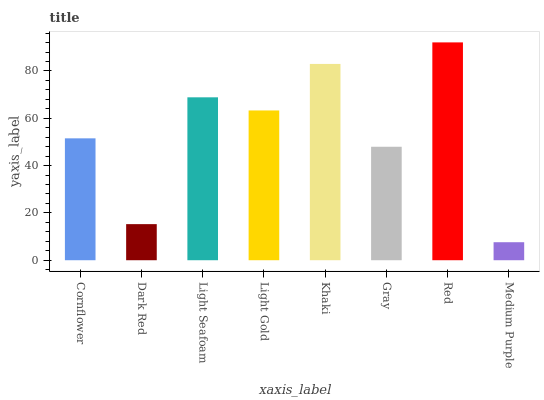Is Dark Red the minimum?
Answer yes or no. No. Is Dark Red the maximum?
Answer yes or no. No. Is Cornflower greater than Dark Red?
Answer yes or no. Yes. Is Dark Red less than Cornflower?
Answer yes or no. Yes. Is Dark Red greater than Cornflower?
Answer yes or no. No. Is Cornflower less than Dark Red?
Answer yes or no. No. Is Light Gold the high median?
Answer yes or no. Yes. Is Cornflower the low median?
Answer yes or no. Yes. Is Medium Purple the high median?
Answer yes or no. No. Is Khaki the low median?
Answer yes or no. No. 